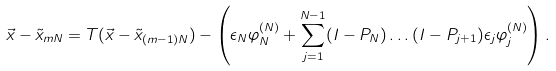<formula> <loc_0><loc_0><loc_500><loc_500>\vec { x } - \tilde { x } _ { m N } = T ( \vec { x } - \tilde { x } _ { ( m - 1 ) N } ) - \left ( \epsilon _ { N } \varphi _ { N } ^ { ( N ) } + \sum _ { j = 1 } ^ { N - 1 } ( I - P _ { N } ) \dots ( I - P _ { j + 1 } ) \epsilon _ { j } \varphi _ { j } ^ { ( N ) } \right ) .</formula> 